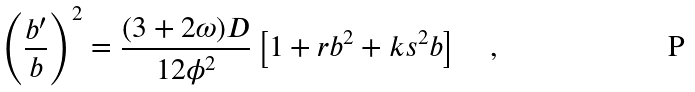<formula> <loc_0><loc_0><loc_500><loc_500>\left ( \frac { b ^ { \prime } } { b } \right ) ^ { 2 } = \frac { ( 3 + 2 \omega ) D } { 1 2 \phi ^ { 2 } } \left [ 1 + r b ^ { 2 } + k s ^ { 2 } b \right ] \quad ,</formula> 